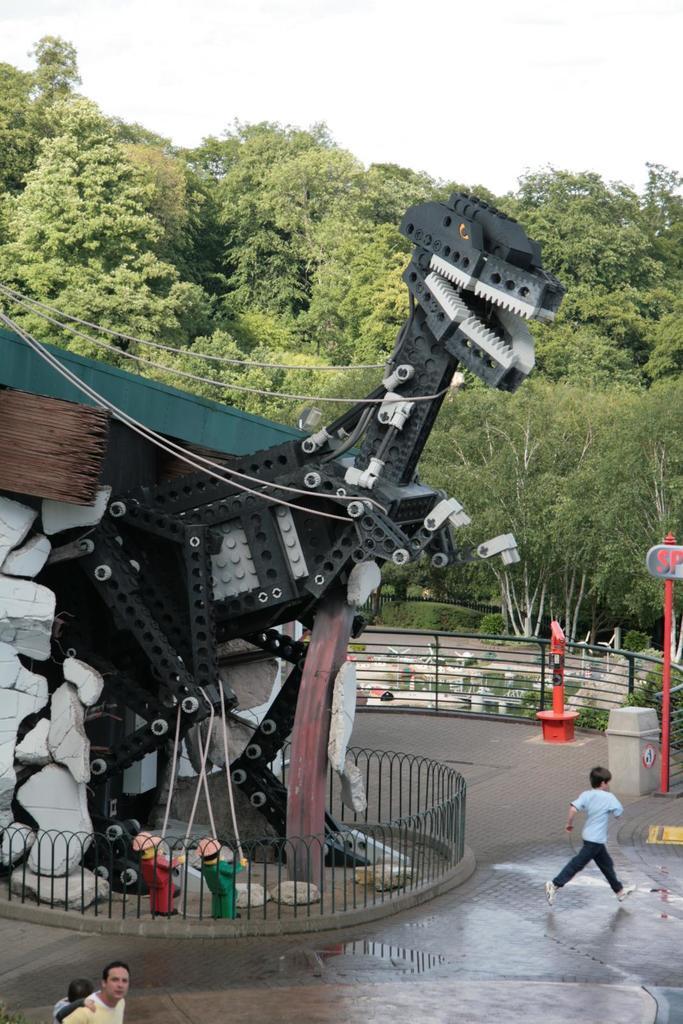Describe this image in one or two sentences. There are people, a model of a dinosaur, it seems like the plants in the foreground area of the image, there are trees and the sky in the background. 